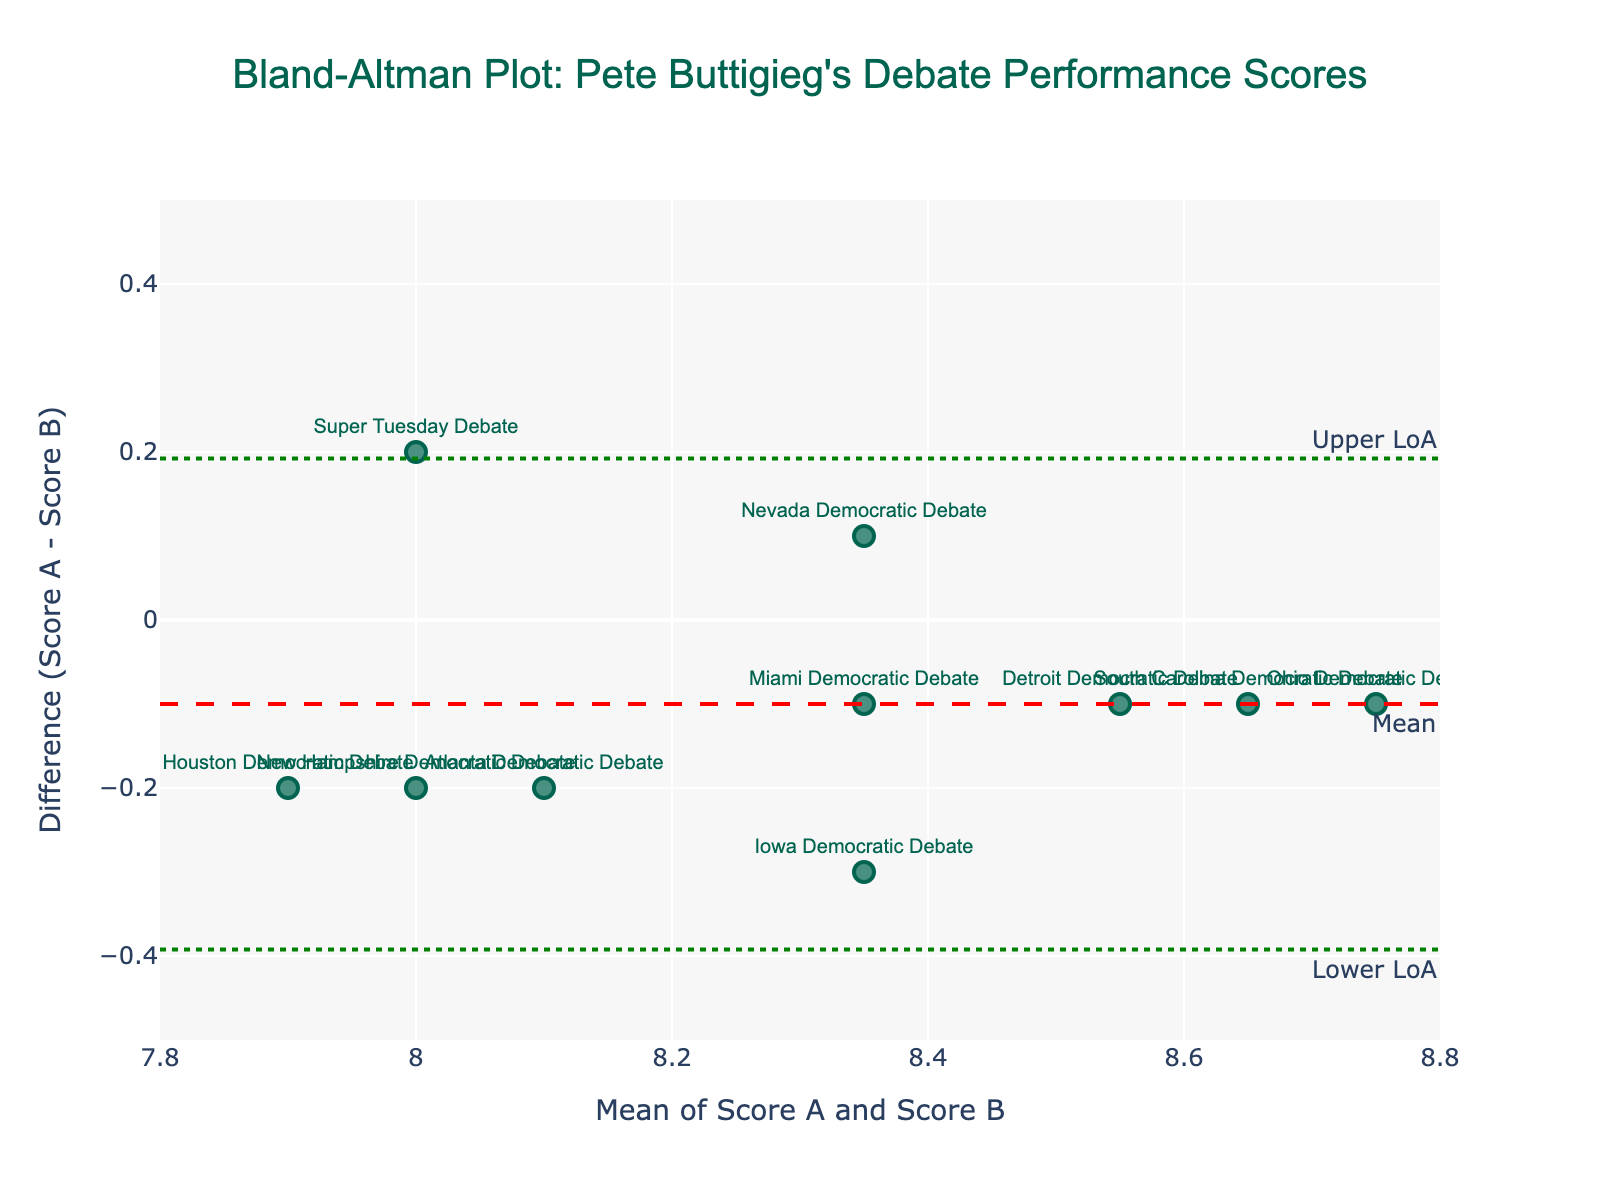What is the title of the plot? The title is usually displayed prominently at the top of the figure. It gives an overview of what the plot represents. Here, it reads "Bland-Altman Plot: Pete Buttigieg's Debate Performance Scores."
Answer: Bland-Altman Plot: Pete Buttigieg's Debate Performance Scores How many data points are represented in the plot? Each debate's mean and difference score pair forms a data point. To determine the number of data points, count the number of points shown on the scatter plot. Each point is labeled with a debate's name.
Answer: 10 What do the x-axis and y-axis represent? The x-axis typically shows the mean of the two scores (Score A and Score B), while the y-axis displays the difference between the two scores (Score A - Score B). This helps in assessing the consistency of the scores.
Answer: Mean of Score A and Score B, Difference (Score A - Score B) Which debate has the highest mean score? Look for the data point farthest to the right on the x-axis as that indicates the highest mean score of the two scores. Compare the text annotations to find which debate it corresponds to.
Answer: Ohio Democratic Debate Which debate has the largest positive difference in scores? The largest positive difference will be the data point highest on the y-axis. Check the y-value and identify the corresponding debate from the text annotations.
Answer: Iowa Democratic Debate Which debate has the smallest difference in scores? The smallest difference will be the data point closest to the y=0 line (either above or below). Compare the y-values to find the smallest absolute value difference and determine the associated debate.
Answer: Nevada Democratic Debate What is the mean difference in scores across the debates? The mean difference is typically indicated by a horizontal dashed line and sometimes labeled "Mean." Look on the y-axis intersection with the red dashed line to find this value.
Answer: Approximately 0 What are the upper and lower limits of agreement? Limits of agreement are often shown as dotted lines above and below the mean difference line. Look for the y-values where these green dotted lines are drawn.
Answer: Approximately +0.28 and -0.28 How does Pete Buttigieg's performance consistency vary between the Iowa and Super Tuesday debates? Compare the x (mean) and y (difference) values for these two debates. Check if both values fall within the limits of agreement and see their relative positioning on the plot.
Answer: Iowa shows a higher mean and a positive difference, Super Tuesday shows a lower mean and a negative difference Are there any debates where the difference in scores is outside the limits of agreement? Check if any data points lie above the upper green dotted line or below the lower green dotted line. These points would indicate inconsistently scored performances.
Answer: No 